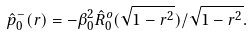<formula> <loc_0><loc_0><loc_500><loc_500>\hat { p } _ { 0 } ^ { - } ( r ) = - \beta _ { 0 } ^ { 2 } \hat { R } _ { 0 } ^ { o } ( \sqrt { 1 - r ^ { 2 } } ) / \sqrt { 1 - r ^ { 2 } } .</formula> 